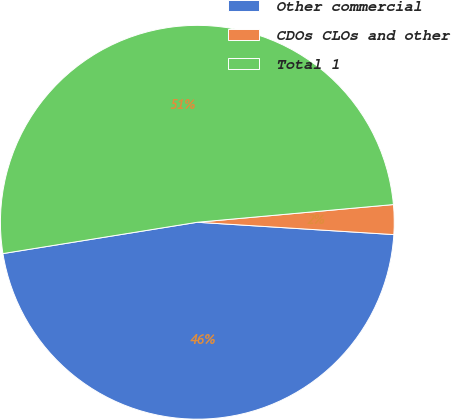Convert chart to OTSL. <chart><loc_0><loc_0><loc_500><loc_500><pie_chart><fcel>Other commercial<fcel>CDOs CLOs and other<fcel>Total 1<nl><fcel>46.46%<fcel>2.43%<fcel>51.11%<nl></chart> 